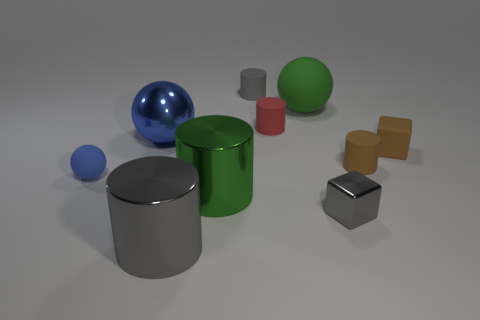What size is the red object that is the same shape as the small gray matte thing?
Keep it short and to the point. Small. Do the green thing behind the blue matte object and the small blue object have the same shape?
Provide a succinct answer. Yes. There is a green thing that is in front of the blue object that is in front of the blue metal ball; what is its shape?
Provide a short and direct response. Cylinder. There is another big object that is the same shape as the big gray thing; what color is it?
Keep it short and to the point. Green. There is a metallic cube; is it the same color as the tiny thing behind the red rubber thing?
Your response must be concise. Yes. The object that is both on the right side of the gray matte cylinder and in front of the blue matte sphere has what shape?
Offer a terse response. Cube. Are there fewer big matte balls than yellow matte cubes?
Give a very brief answer. No. Are there any large cubes?
Make the answer very short. No. What number of other things are the same size as the brown cylinder?
Offer a terse response. 5. Are the red object and the small gray thing that is on the right side of the gray matte object made of the same material?
Offer a terse response. No. 